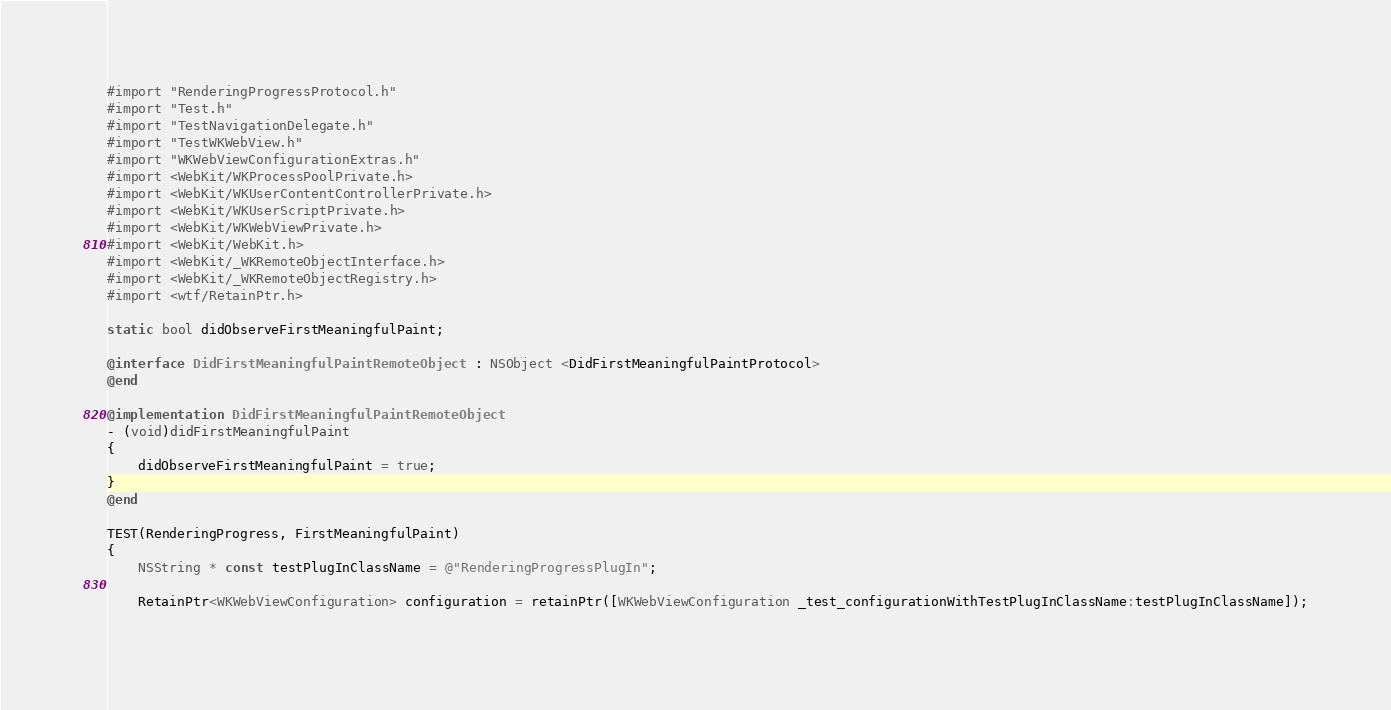<code> <loc_0><loc_0><loc_500><loc_500><_ObjectiveC_>#import "RenderingProgressProtocol.h"
#import "Test.h"
#import "TestNavigationDelegate.h"
#import "TestWKWebView.h"
#import "WKWebViewConfigurationExtras.h"
#import <WebKit/WKProcessPoolPrivate.h>
#import <WebKit/WKUserContentControllerPrivate.h>
#import <WebKit/WKUserScriptPrivate.h>
#import <WebKit/WKWebViewPrivate.h>
#import <WebKit/WebKit.h>
#import <WebKit/_WKRemoteObjectInterface.h>
#import <WebKit/_WKRemoteObjectRegistry.h>
#import <wtf/RetainPtr.h>

static bool didObserveFirstMeaningfulPaint;

@interface DidFirstMeaningfulPaintRemoteObject : NSObject <DidFirstMeaningfulPaintProtocol>
@end

@implementation DidFirstMeaningfulPaintRemoteObject
- (void)didFirstMeaningfulPaint
{
    didObserveFirstMeaningfulPaint = true;
}
@end

TEST(RenderingProgress, FirstMeaningfulPaint)
{
    NSString * const testPlugInClassName = @"RenderingProgressPlugIn";

    RetainPtr<WKWebViewConfiguration> configuration = retainPtr([WKWebViewConfiguration _test_configurationWithTestPlugInClassName:testPlugInClassName]);
    </code> 